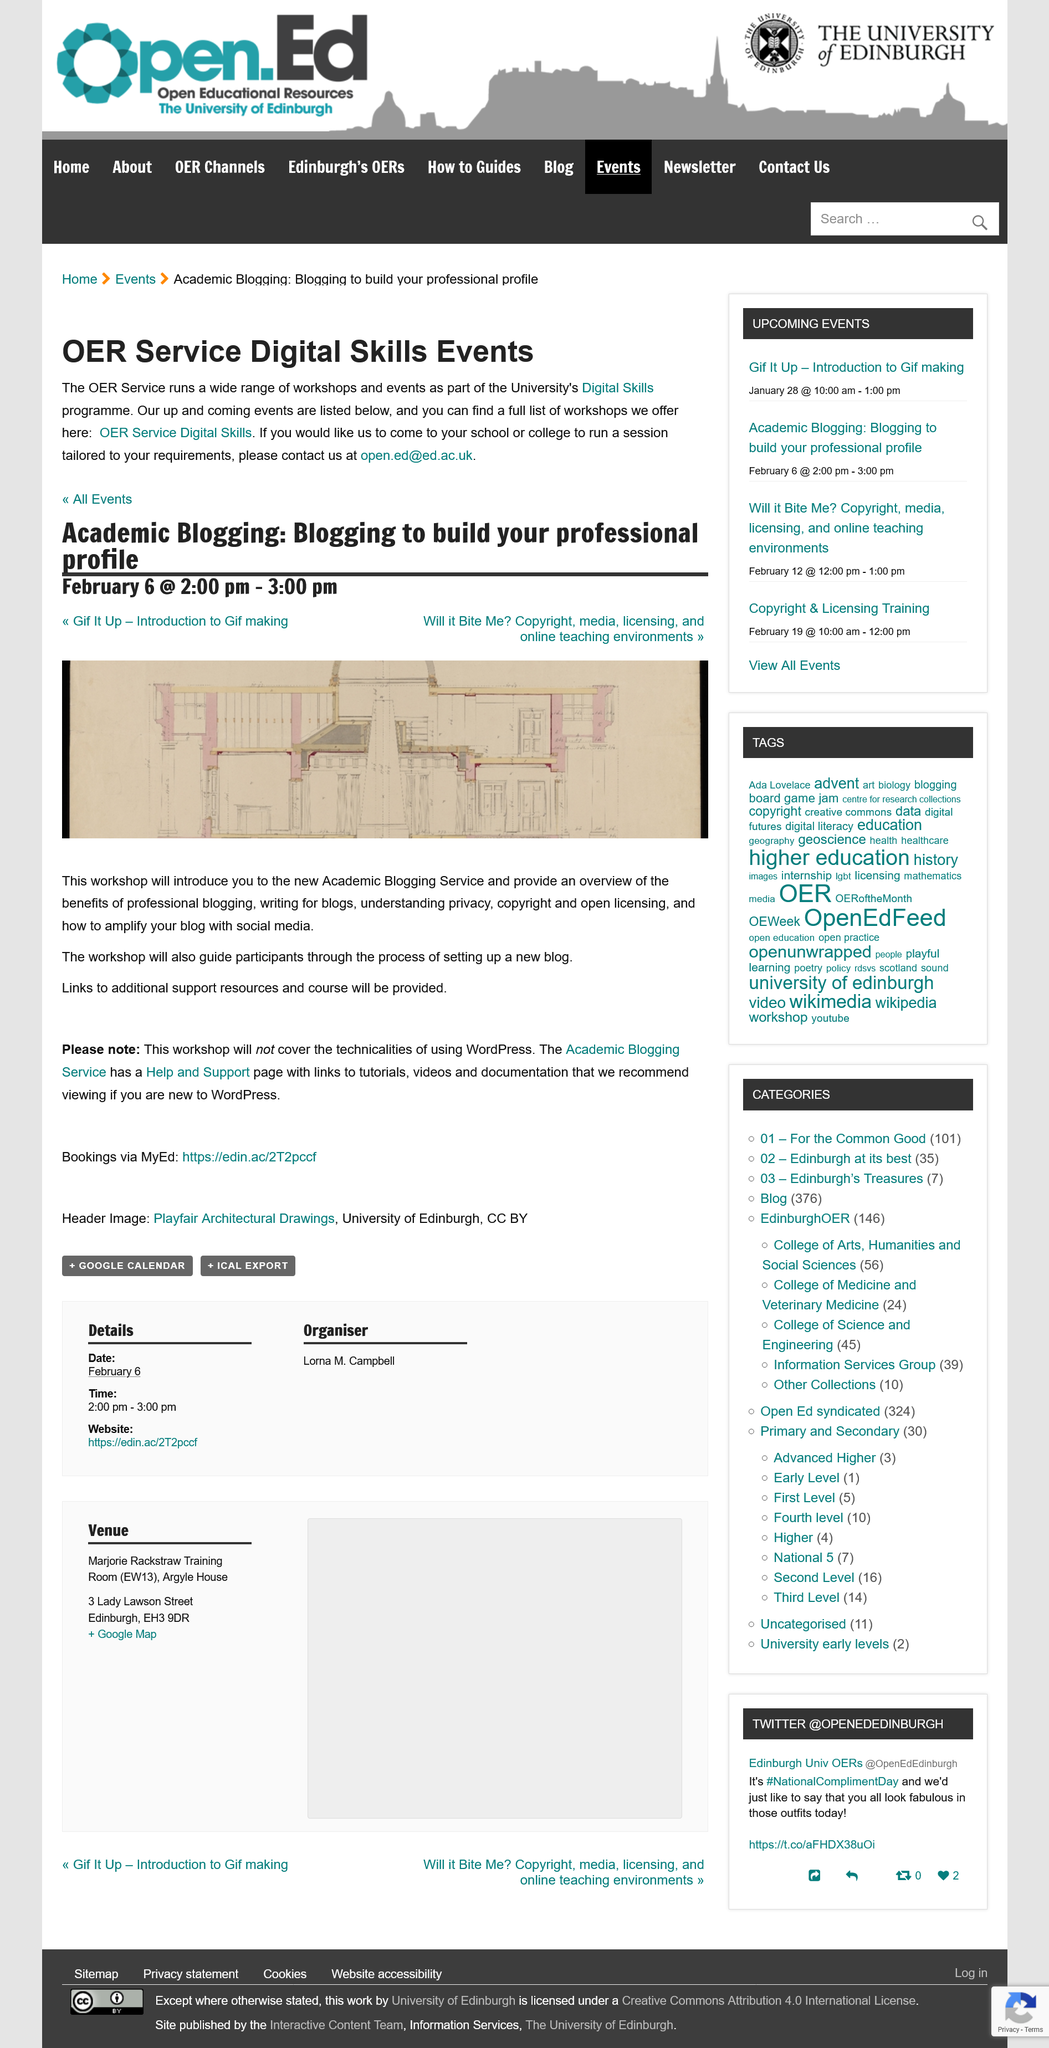Specify some key components in this picture. The workshop will cover the basics of academic blogging. The workshop does not cover Wordpress. The workshop can assist in setting up a blog. 